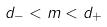Convert formula to latex. <formula><loc_0><loc_0><loc_500><loc_500>d _ { - } < m < d _ { + }</formula> 